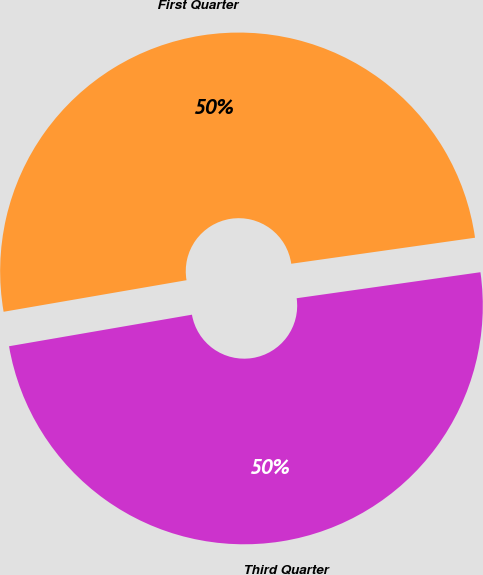<chart> <loc_0><loc_0><loc_500><loc_500><pie_chart><fcel>First Quarter<fcel>Third Quarter<nl><fcel>50.48%<fcel>49.52%<nl></chart> 